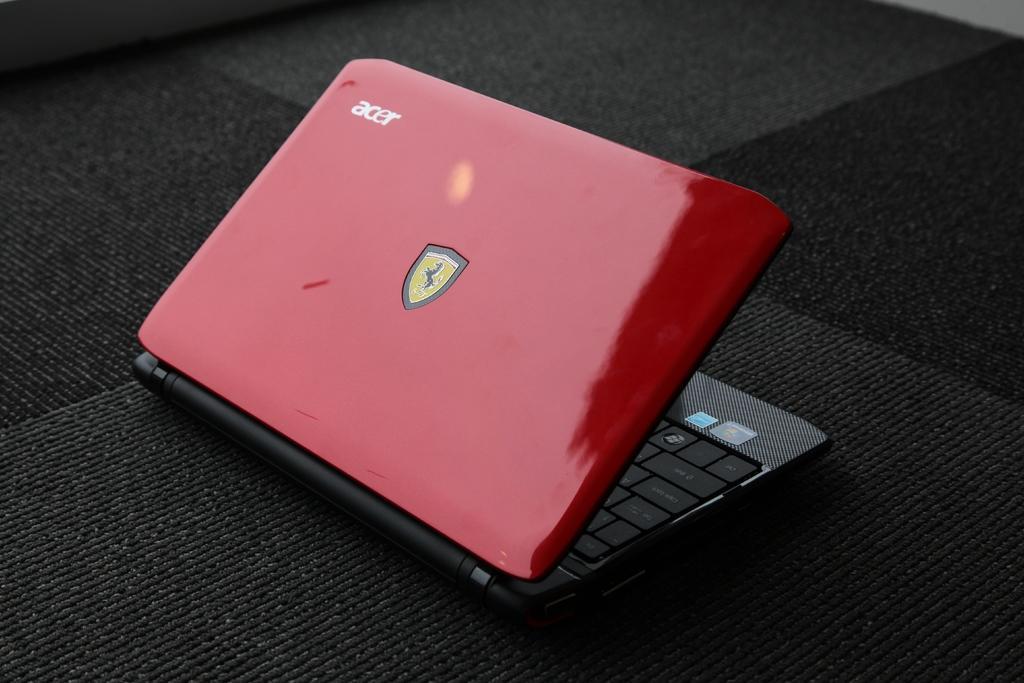Can you describe this image briefly? In the picture we can see a laptop which is red in color with a Ferrari symbol on it and a name ACER on it and it is placed on the black color mat. 